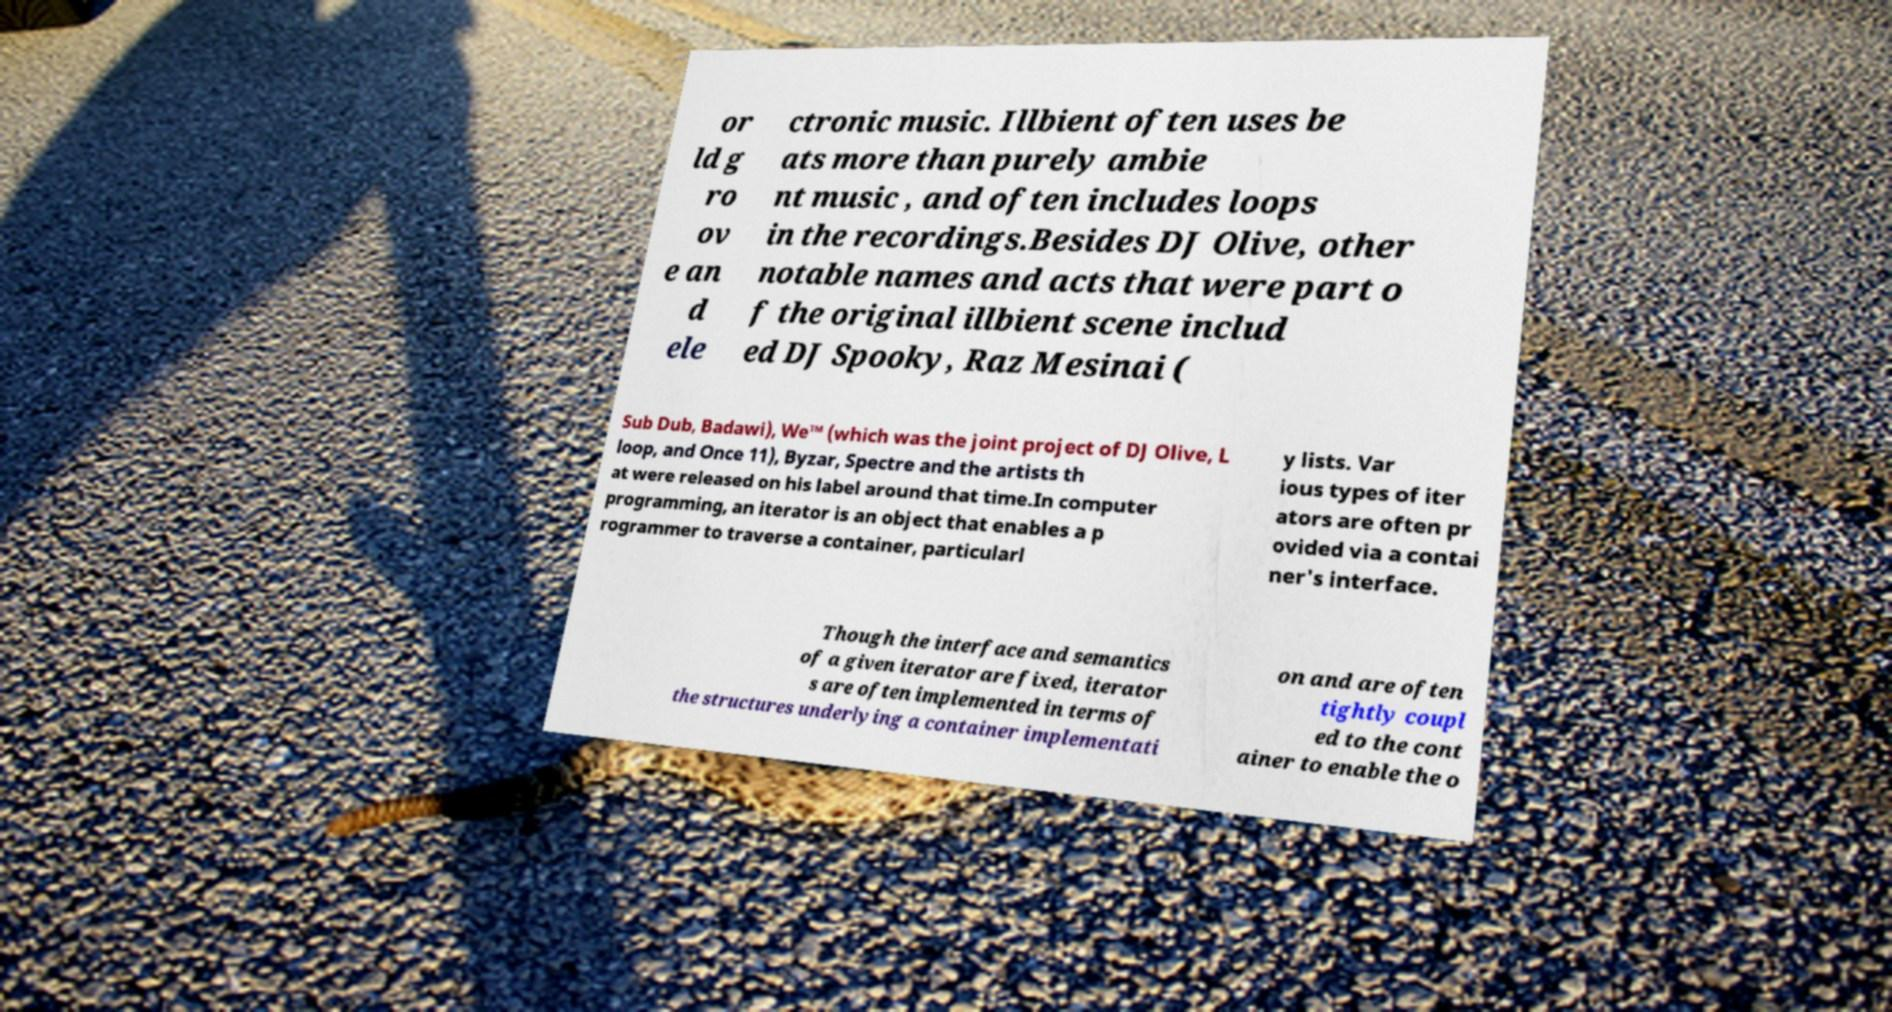There's text embedded in this image that I need extracted. Can you transcribe it verbatim? or ld g ro ov e an d ele ctronic music. Illbient often uses be ats more than purely ambie nt music , and often includes loops in the recordings.Besides DJ Olive, other notable names and acts that were part o f the original illbient scene includ ed DJ Spooky, Raz Mesinai ( Sub Dub, Badawi), We™ (which was the joint project of DJ Olive, L loop, and Once 11), Byzar, Spectre and the artists th at were released on his label around that time.In computer programming, an iterator is an object that enables a p rogrammer to traverse a container, particularl y lists. Var ious types of iter ators are often pr ovided via a contai ner's interface. Though the interface and semantics of a given iterator are fixed, iterator s are often implemented in terms of the structures underlying a container implementati on and are often tightly coupl ed to the cont ainer to enable the o 